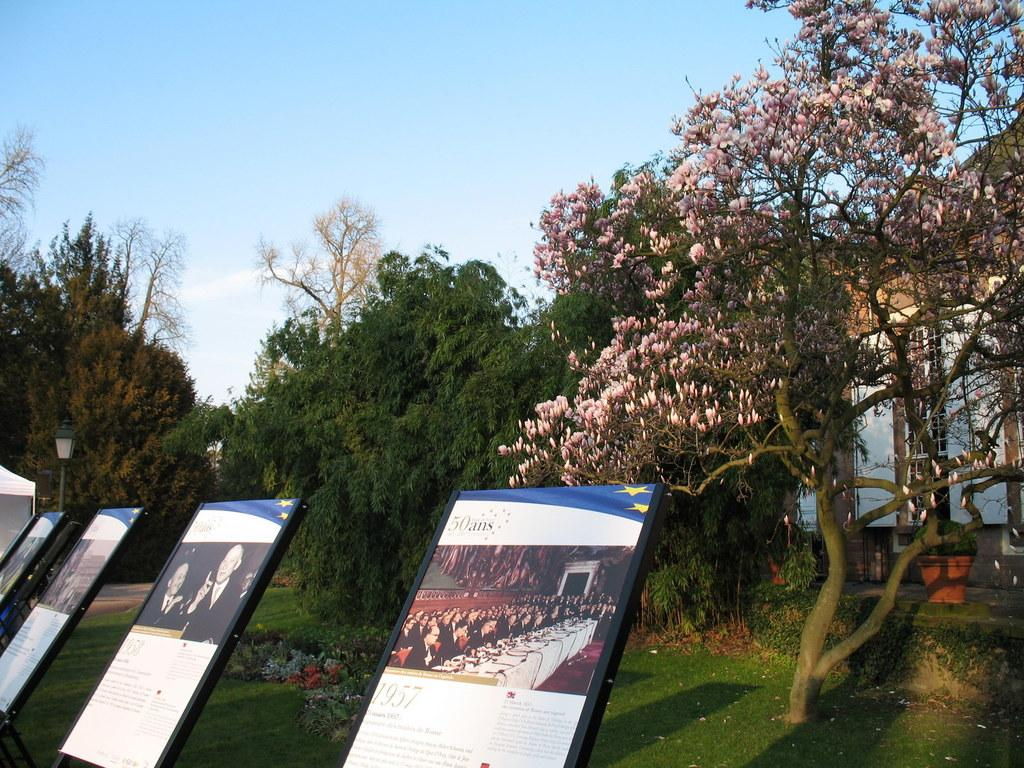What objects are located at the bottom of the image? There are display boards present at the bottom of the image. What type of natural scenery can be seen in the background of the image? There are trees in the background of the image. What is visible at the top of the image? The sky is visible at the top of the image. Can you see a needle sticking out of the wall in the image? There is no needle or wall present in the image. 